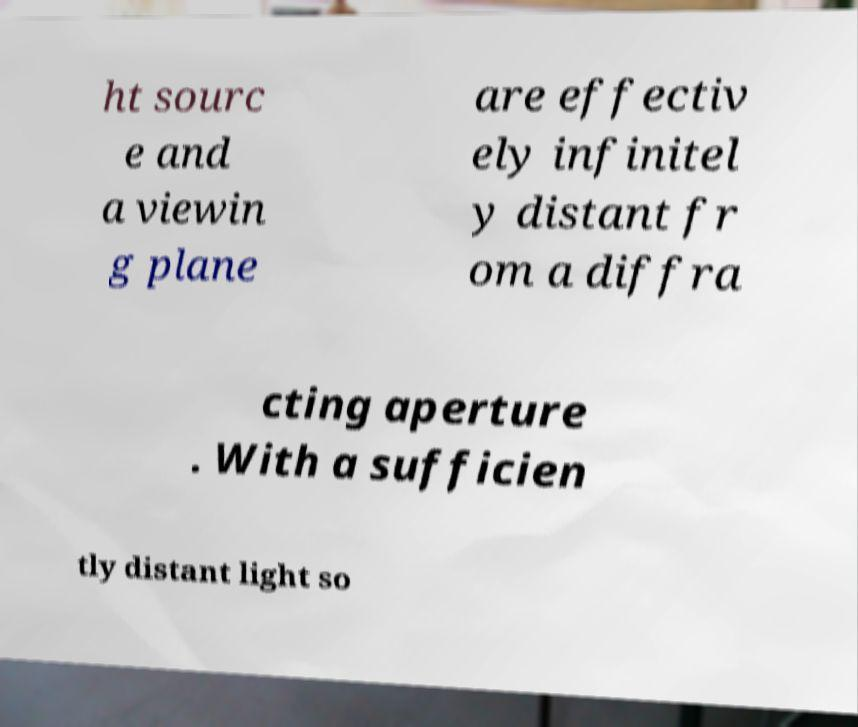Could you extract and type out the text from this image? ht sourc e and a viewin g plane are effectiv ely infinitel y distant fr om a diffra cting aperture . With a sufficien tly distant light so 